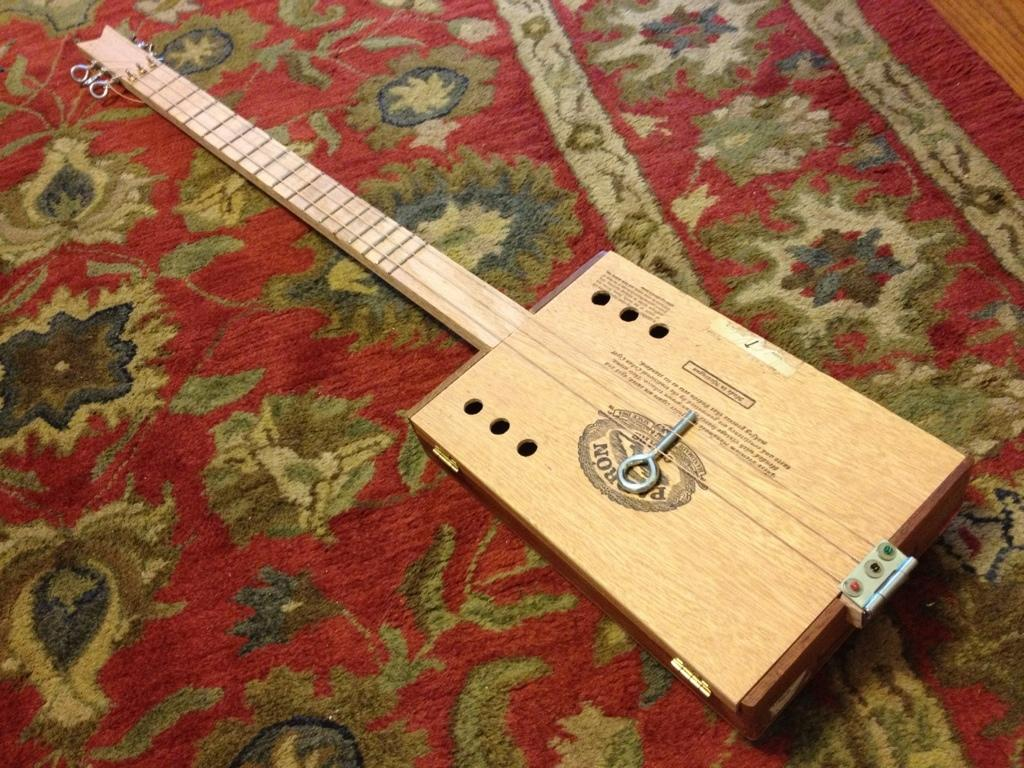What object in the image is used for creating music? There is a musical instrument in the image. Can you describe the surface on which the musical instrument is placed? The musical instrument is on a carpet. What type of ornament is hanging from the musical instrument in the image? There is no ornament hanging from the musical instrument in the image. What type of record can be seen playing on the musical instrument in the image? There is no record or any indication of a record being played on the musical instrument in the image. 